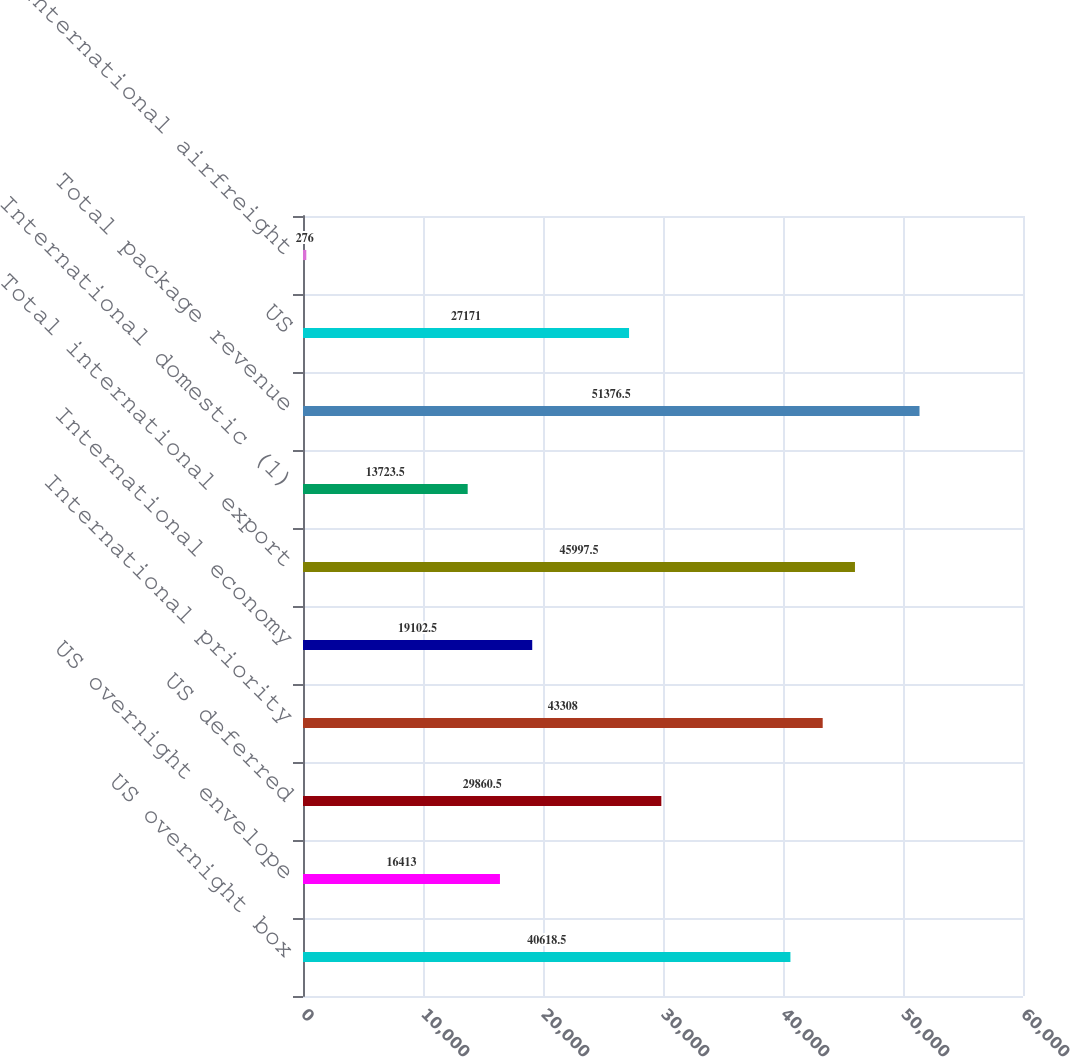Convert chart. <chart><loc_0><loc_0><loc_500><loc_500><bar_chart><fcel>US overnight box<fcel>US overnight envelope<fcel>US deferred<fcel>International priority<fcel>International economy<fcel>Total international export<fcel>International domestic (1)<fcel>Total package revenue<fcel>US<fcel>International airfreight<nl><fcel>40618.5<fcel>16413<fcel>29860.5<fcel>43308<fcel>19102.5<fcel>45997.5<fcel>13723.5<fcel>51376.5<fcel>27171<fcel>276<nl></chart> 